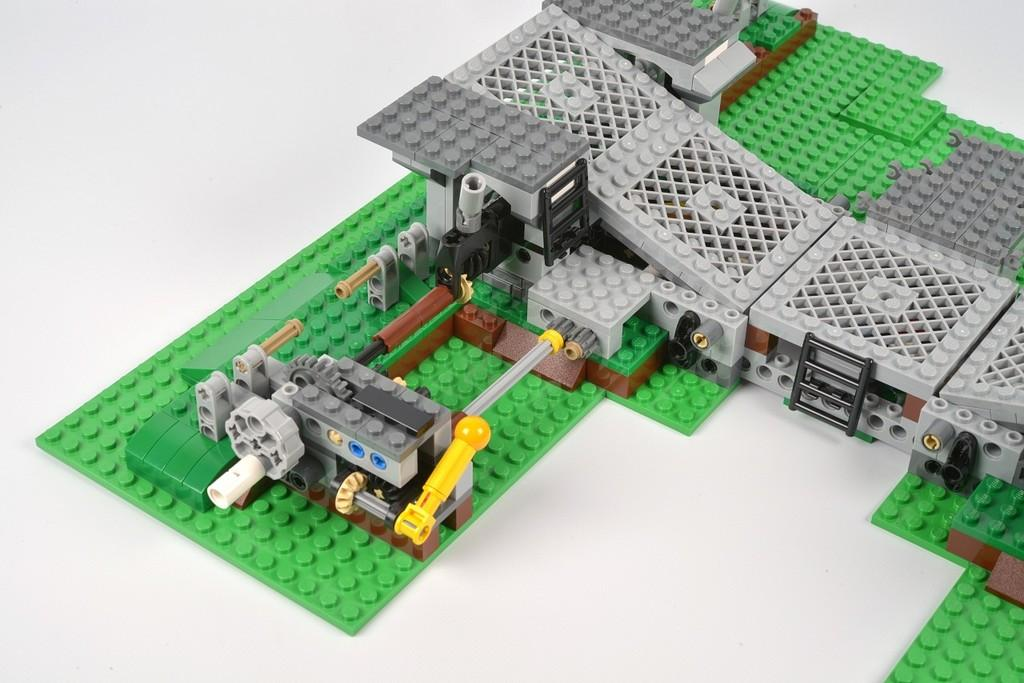What type of toys are in the image? There are Lego toys in the image. What colors can be seen among the Lego toys? The Lego toys are of various colors, including green, grey, white, blue, black, and yellow. What is the surface on which the Lego toys are placed? The toys are on a white surface. Can you see any people walking along the coast in the image? There is no coast or people walking in the image; it features Lego toys on a white surface. 